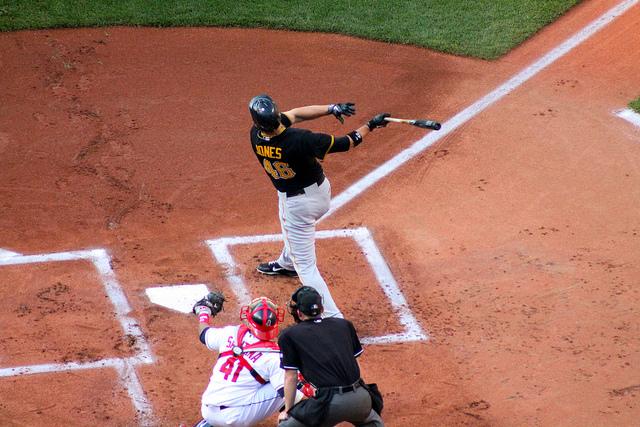What is the name of the position directly behind the batter?
Answer briefly. Catcher. Did the catcher get the ball?
Write a very short answer. Yes. What is the batters number?
Short answer required. 48. 